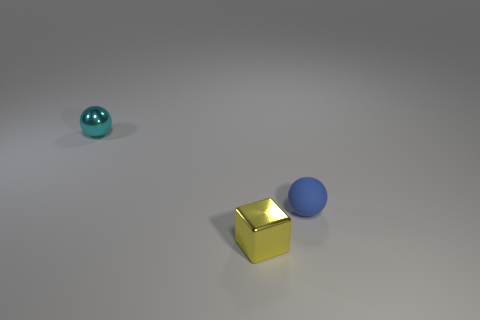Add 3 small green rubber things. How many objects exist? 6 Subtract all blocks. How many objects are left? 2 Add 1 tiny purple metallic blocks. How many tiny purple metallic blocks exist? 1 Subtract 0 blue blocks. How many objects are left? 3 Subtract all brown metal objects. Subtract all small cyan things. How many objects are left? 2 Add 3 blocks. How many blocks are left? 4 